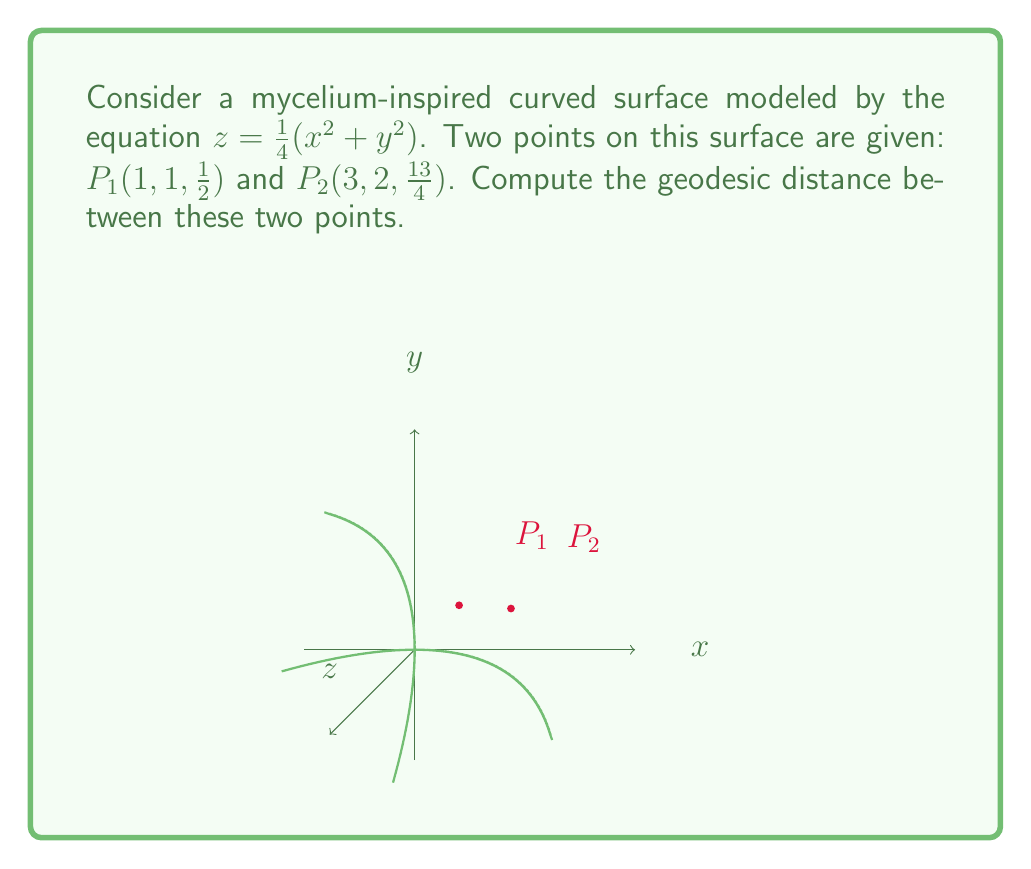Solve this math problem. To compute the geodesic distance between two points on a curved surface, we need to follow these steps:

1) First, we need to find the metric tensor of the surface. The surface is given by $z = \frac{1}{4}(x^2 + y^2)$. We can parameterize this surface as:

   $\mathbf{r}(x,y) = (x, y, \frac{1}{4}(x^2 + y^2))$

2) The metric tensor $g_{ij}$ is given by:

   $g_{ij} = \frac{\partial \mathbf{r}}{\partial x_i} \cdot \frac{\partial \mathbf{r}}{\partial x_j}$

   where $x_1 = x$ and $x_2 = y$.

3) Computing the partial derivatives:

   $\frac{\partial \mathbf{r}}{\partial x} = (1, 0, \frac{1}{2}x)$
   $\frac{\partial \mathbf{r}}{\partial y} = (0, 1, \frac{1}{2}y)$

4) Now we can compute the metric tensor:

   $g_{11} = 1 + \frac{1}{4}x^2$
   $g_{12} = g_{21} = \frac{1}{4}xy$
   $g_{22} = 1 + \frac{1}{4}y^2$

5) The geodesic equation is given by:

   $\frac{d^2x^i}{dt^2} + \Gamma^i_{jk}\frac{dx^j}{dt}\frac{dx^k}{dt} = 0$

   where $\Gamma^i_{jk}$ are the Christoffel symbols.

6) Solving this equation analytically is complex for this surface. Instead, we can use a numerical approximation.

7) One common approximation is to use the Euclidean distance in the ambient space as an upper bound for the geodesic distance:

   $d \approx \sqrt{(x_2-x_1)^2 + (y_2-y_1)^2 + (z_2-z_1)^2}$

8) Plugging in our points:

   $d \approx \sqrt{(3-1)^2 + (2-1)^2 + (\frac{13}{4}-\frac{1}{2})^2}$

9) Simplifying:

   $d \approx \sqrt{4 + 1 + (\frac{11}{4})^2} = \sqrt{4 + 1 + \frac{121}{16}} = \sqrt{\frac{64 + 16 + 121}{16}} = \sqrt{\frac{201}{16}} = \frac{\sqrt{201}}{4}$

This is an upper bound for the true geodesic distance. The actual geodesic distance would be slightly shorter than this Euclidean distance.
Answer: $\frac{\sqrt{201}}{4}$ (upper bound) 